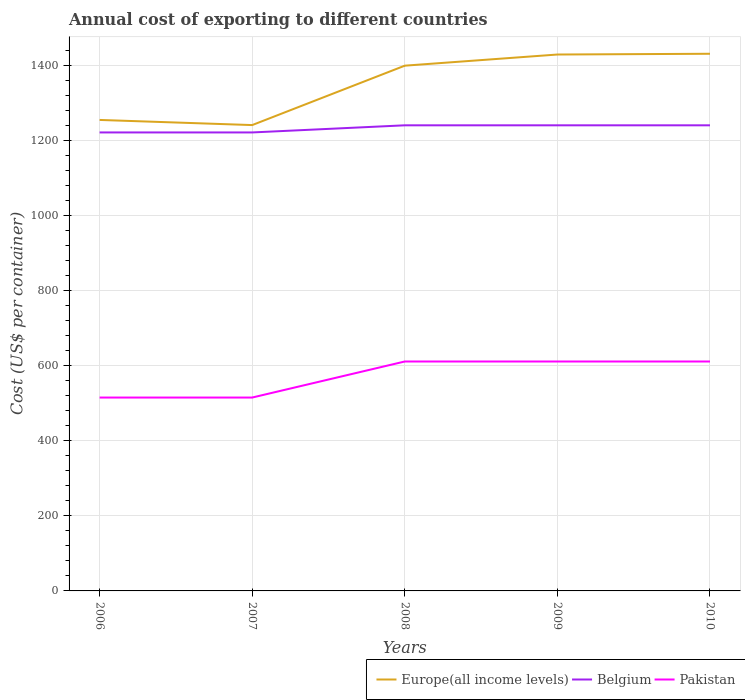Across all years, what is the maximum total annual cost of exporting in Pakistan?
Your answer should be compact. 515. What is the total total annual cost of exporting in Pakistan in the graph?
Give a very brief answer. 0. What is the difference between the highest and the second highest total annual cost of exporting in Belgium?
Keep it short and to the point. 19. What is the difference between the highest and the lowest total annual cost of exporting in Pakistan?
Your answer should be compact. 3. How many lines are there?
Offer a terse response. 3. Does the graph contain grids?
Provide a short and direct response. Yes. How many legend labels are there?
Your response must be concise. 3. How are the legend labels stacked?
Provide a succinct answer. Horizontal. What is the title of the graph?
Your answer should be compact. Annual cost of exporting to different countries. Does "Ghana" appear as one of the legend labels in the graph?
Your answer should be very brief. No. What is the label or title of the Y-axis?
Make the answer very short. Cost (US$ per container). What is the Cost (US$ per container) of Europe(all income levels) in 2006?
Your answer should be compact. 1254.33. What is the Cost (US$ per container) of Belgium in 2006?
Ensure brevity in your answer.  1221. What is the Cost (US$ per container) of Pakistan in 2006?
Offer a very short reply. 515. What is the Cost (US$ per container) of Europe(all income levels) in 2007?
Your response must be concise. 1240.63. What is the Cost (US$ per container) of Belgium in 2007?
Your answer should be compact. 1221. What is the Cost (US$ per container) in Pakistan in 2007?
Your answer should be compact. 515. What is the Cost (US$ per container) in Europe(all income levels) in 2008?
Provide a succinct answer. 1398.83. What is the Cost (US$ per container) in Belgium in 2008?
Offer a very short reply. 1240. What is the Cost (US$ per container) in Pakistan in 2008?
Give a very brief answer. 611. What is the Cost (US$ per container) in Europe(all income levels) in 2009?
Give a very brief answer. 1428.52. What is the Cost (US$ per container) in Belgium in 2009?
Your answer should be compact. 1240. What is the Cost (US$ per container) in Pakistan in 2009?
Offer a terse response. 611. What is the Cost (US$ per container) in Europe(all income levels) in 2010?
Your answer should be compact. 1430.54. What is the Cost (US$ per container) of Belgium in 2010?
Offer a very short reply. 1240. What is the Cost (US$ per container) in Pakistan in 2010?
Make the answer very short. 611. Across all years, what is the maximum Cost (US$ per container) of Europe(all income levels)?
Your answer should be very brief. 1430.54. Across all years, what is the maximum Cost (US$ per container) in Belgium?
Your answer should be compact. 1240. Across all years, what is the maximum Cost (US$ per container) in Pakistan?
Your response must be concise. 611. Across all years, what is the minimum Cost (US$ per container) of Europe(all income levels)?
Keep it short and to the point. 1240.63. Across all years, what is the minimum Cost (US$ per container) of Belgium?
Offer a very short reply. 1221. Across all years, what is the minimum Cost (US$ per container) in Pakistan?
Make the answer very short. 515. What is the total Cost (US$ per container) of Europe(all income levels) in the graph?
Your answer should be very brief. 6752.85. What is the total Cost (US$ per container) in Belgium in the graph?
Provide a short and direct response. 6162. What is the total Cost (US$ per container) of Pakistan in the graph?
Your answer should be very brief. 2863. What is the difference between the Cost (US$ per container) of Europe(all income levels) in 2006 and that in 2007?
Provide a short and direct response. 13.7. What is the difference between the Cost (US$ per container) of Europe(all income levels) in 2006 and that in 2008?
Ensure brevity in your answer.  -144.5. What is the difference between the Cost (US$ per container) of Pakistan in 2006 and that in 2008?
Your response must be concise. -96. What is the difference between the Cost (US$ per container) of Europe(all income levels) in 2006 and that in 2009?
Give a very brief answer. -174.19. What is the difference between the Cost (US$ per container) of Pakistan in 2006 and that in 2009?
Offer a terse response. -96. What is the difference between the Cost (US$ per container) of Europe(all income levels) in 2006 and that in 2010?
Keep it short and to the point. -176.22. What is the difference between the Cost (US$ per container) in Pakistan in 2006 and that in 2010?
Provide a short and direct response. -96. What is the difference between the Cost (US$ per container) of Europe(all income levels) in 2007 and that in 2008?
Your answer should be compact. -158.2. What is the difference between the Cost (US$ per container) in Pakistan in 2007 and that in 2008?
Keep it short and to the point. -96. What is the difference between the Cost (US$ per container) in Europe(all income levels) in 2007 and that in 2009?
Your answer should be compact. -187.89. What is the difference between the Cost (US$ per container) in Belgium in 2007 and that in 2009?
Your response must be concise. -19. What is the difference between the Cost (US$ per container) of Pakistan in 2007 and that in 2009?
Offer a terse response. -96. What is the difference between the Cost (US$ per container) of Europe(all income levels) in 2007 and that in 2010?
Offer a very short reply. -189.91. What is the difference between the Cost (US$ per container) in Belgium in 2007 and that in 2010?
Keep it short and to the point. -19. What is the difference between the Cost (US$ per container) of Pakistan in 2007 and that in 2010?
Provide a succinct answer. -96. What is the difference between the Cost (US$ per container) of Europe(all income levels) in 2008 and that in 2009?
Offer a very short reply. -29.69. What is the difference between the Cost (US$ per container) of Pakistan in 2008 and that in 2009?
Give a very brief answer. 0. What is the difference between the Cost (US$ per container) in Europe(all income levels) in 2008 and that in 2010?
Your answer should be compact. -31.71. What is the difference between the Cost (US$ per container) of Belgium in 2008 and that in 2010?
Your answer should be compact. 0. What is the difference between the Cost (US$ per container) of Pakistan in 2008 and that in 2010?
Offer a very short reply. 0. What is the difference between the Cost (US$ per container) of Europe(all income levels) in 2009 and that in 2010?
Your response must be concise. -2.02. What is the difference between the Cost (US$ per container) in Pakistan in 2009 and that in 2010?
Make the answer very short. 0. What is the difference between the Cost (US$ per container) of Europe(all income levels) in 2006 and the Cost (US$ per container) of Belgium in 2007?
Your answer should be compact. 33.33. What is the difference between the Cost (US$ per container) in Europe(all income levels) in 2006 and the Cost (US$ per container) in Pakistan in 2007?
Your answer should be compact. 739.33. What is the difference between the Cost (US$ per container) in Belgium in 2006 and the Cost (US$ per container) in Pakistan in 2007?
Offer a terse response. 706. What is the difference between the Cost (US$ per container) of Europe(all income levels) in 2006 and the Cost (US$ per container) of Belgium in 2008?
Make the answer very short. 14.33. What is the difference between the Cost (US$ per container) of Europe(all income levels) in 2006 and the Cost (US$ per container) of Pakistan in 2008?
Ensure brevity in your answer.  643.33. What is the difference between the Cost (US$ per container) in Belgium in 2006 and the Cost (US$ per container) in Pakistan in 2008?
Give a very brief answer. 610. What is the difference between the Cost (US$ per container) of Europe(all income levels) in 2006 and the Cost (US$ per container) of Belgium in 2009?
Ensure brevity in your answer.  14.33. What is the difference between the Cost (US$ per container) in Europe(all income levels) in 2006 and the Cost (US$ per container) in Pakistan in 2009?
Offer a very short reply. 643.33. What is the difference between the Cost (US$ per container) in Belgium in 2006 and the Cost (US$ per container) in Pakistan in 2009?
Give a very brief answer. 610. What is the difference between the Cost (US$ per container) in Europe(all income levels) in 2006 and the Cost (US$ per container) in Belgium in 2010?
Offer a very short reply. 14.33. What is the difference between the Cost (US$ per container) of Europe(all income levels) in 2006 and the Cost (US$ per container) of Pakistan in 2010?
Give a very brief answer. 643.33. What is the difference between the Cost (US$ per container) in Belgium in 2006 and the Cost (US$ per container) in Pakistan in 2010?
Provide a succinct answer. 610. What is the difference between the Cost (US$ per container) of Europe(all income levels) in 2007 and the Cost (US$ per container) of Belgium in 2008?
Ensure brevity in your answer.  0.63. What is the difference between the Cost (US$ per container) in Europe(all income levels) in 2007 and the Cost (US$ per container) in Pakistan in 2008?
Your response must be concise. 629.63. What is the difference between the Cost (US$ per container) in Belgium in 2007 and the Cost (US$ per container) in Pakistan in 2008?
Your answer should be very brief. 610. What is the difference between the Cost (US$ per container) in Europe(all income levels) in 2007 and the Cost (US$ per container) in Belgium in 2009?
Provide a short and direct response. 0.63. What is the difference between the Cost (US$ per container) of Europe(all income levels) in 2007 and the Cost (US$ per container) of Pakistan in 2009?
Provide a short and direct response. 629.63. What is the difference between the Cost (US$ per container) in Belgium in 2007 and the Cost (US$ per container) in Pakistan in 2009?
Your answer should be very brief. 610. What is the difference between the Cost (US$ per container) of Europe(all income levels) in 2007 and the Cost (US$ per container) of Belgium in 2010?
Make the answer very short. 0.63. What is the difference between the Cost (US$ per container) in Europe(all income levels) in 2007 and the Cost (US$ per container) in Pakistan in 2010?
Offer a very short reply. 629.63. What is the difference between the Cost (US$ per container) in Belgium in 2007 and the Cost (US$ per container) in Pakistan in 2010?
Your answer should be compact. 610. What is the difference between the Cost (US$ per container) in Europe(all income levels) in 2008 and the Cost (US$ per container) in Belgium in 2009?
Your response must be concise. 158.83. What is the difference between the Cost (US$ per container) of Europe(all income levels) in 2008 and the Cost (US$ per container) of Pakistan in 2009?
Keep it short and to the point. 787.83. What is the difference between the Cost (US$ per container) in Belgium in 2008 and the Cost (US$ per container) in Pakistan in 2009?
Keep it short and to the point. 629. What is the difference between the Cost (US$ per container) in Europe(all income levels) in 2008 and the Cost (US$ per container) in Belgium in 2010?
Your response must be concise. 158.83. What is the difference between the Cost (US$ per container) of Europe(all income levels) in 2008 and the Cost (US$ per container) of Pakistan in 2010?
Your response must be concise. 787.83. What is the difference between the Cost (US$ per container) of Belgium in 2008 and the Cost (US$ per container) of Pakistan in 2010?
Give a very brief answer. 629. What is the difference between the Cost (US$ per container) of Europe(all income levels) in 2009 and the Cost (US$ per container) of Belgium in 2010?
Your answer should be very brief. 188.52. What is the difference between the Cost (US$ per container) in Europe(all income levels) in 2009 and the Cost (US$ per container) in Pakistan in 2010?
Offer a terse response. 817.52. What is the difference between the Cost (US$ per container) in Belgium in 2009 and the Cost (US$ per container) in Pakistan in 2010?
Provide a succinct answer. 629. What is the average Cost (US$ per container) in Europe(all income levels) per year?
Offer a very short reply. 1350.57. What is the average Cost (US$ per container) in Belgium per year?
Offer a terse response. 1232.4. What is the average Cost (US$ per container) of Pakistan per year?
Your answer should be compact. 572.6. In the year 2006, what is the difference between the Cost (US$ per container) of Europe(all income levels) and Cost (US$ per container) of Belgium?
Your response must be concise. 33.33. In the year 2006, what is the difference between the Cost (US$ per container) in Europe(all income levels) and Cost (US$ per container) in Pakistan?
Offer a terse response. 739.33. In the year 2006, what is the difference between the Cost (US$ per container) of Belgium and Cost (US$ per container) of Pakistan?
Offer a terse response. 706. In the year 2007, what is the difference between the Cost (US$ per container) of Europe(all income levels) and Cost (US$ per container) of Belgium?
Offer a terse response. 19.63. In the year 2007, what is the difference between the Cost (US$ per container) of Europe(all income levels) and Cost (US$ per container) of Pakistan?
Your answer should be very brief. 725.63. In the year 2007, what is the difference between the Cost (US$ per container) of Belgium and Cost (US$ per container) of Pakistan?
Your answer should be very brief. 706. In the year 2008, what is the difference between the Cost (US$ per container) in Europe(all income levels) and Cost (US$ per container) in Belgium?
Provide a short and direct response. 158.83. In the year 2008, what is the difference between the Cost (US$ per container) of Europe(all income levels) and Cost (US$ per container) of Pakistan?
Provide a short and direct response. 787.83. In the year 2008, what is the difference between the Cost (US$ per container) of Belgium and Cost (US$ per container) of Pakistan?
Provide a short and direct response. 629. In the year 2009, what is the difference between the Cost (US$ per container) of Europe(all income levels) and Cost (US$ per container) of Belgium?
Your answer should be compact. 188.52. In the year 2009, what is the difference between the Cost (US$ per container) in Europe(all income levels) and Cost (US$ per container) in Pakistan?
Your answer should be very brief. 817.52. In the year 2009, what is the difference between the Cost (US$ per container) in Belgium and Cost (US$ per container) in Pakistan?
Offer a terse response. 629. In the year 2010, what is the difference between the Cost (US$ per container) of Europe(all income levels) and Cost (US$ per container) of Belgium?
Offer a very short reply. 190.54. In the year 2010, what is the difference between the Cost (US$ per container) in Europe(all income levels) and Cost (US$ per container) in Pakistan?
Provide a succinct answer. 819.54. In the year 2010, what is the difference between the Cost (US$ per container) of Belgium and Cost (US$ per container) of Pakistan?
Provide a short and direct response. 629. What is the ratio of the Cost (US$ per container) of Belgium in 2006 to that in 2007?
Your answer should be very brief. 1. What is the ratio of the Cost (US$ per container) of Europe(all income levels) in 2006 to that in 2008?
Make the answer very short. 0.9. What is the ratio of the Cost (US$ per container) in Belgium in 2006 to that in 2008?
Your answer should be very brief. 0.98. What is the ratio of the Cost (US$ per container) of Pakistan in 2006 to that in 2008?
Your response must be concise. 0.84. What is the ratio of the Cost (US$ per container) of Europe(all income levels) in 2006 to that in 2009?
Provide a succinct answer. 0.88. What is the ratio of the Cost (US$ per container) in Belgium in 2006 to that in 2009?
Provide a succinct answer. 0.98. What is the ratio of the Cost (US$ per container) in Pakistan in 2006 to that in 2009?
Offer a very short reply. 0.84. What is the ratio of the Cost (US$ per container) in Europe(all income levels) in 2006 to that in 2010?
Your answer should be very brief. 0.88. What is the ratio of the Cost (US$ per container) in Belgium in 2006 to that in 2010?
Make the answer very short. 0.98. What is the ratio of the Cost (US$ per container) in Pakistan in 2006 to that in 2010?
Offer a terse response. 0.84. What is the ratio of the Cost (US$ per container) in Europe(all income levels) in 2007 to that in 2008?
Keep it short and to the point. 0.89. What is the ratio of the Cost (US$ per container) of Belgium in 2007 to that in 2008?
Make the answer very short. 0.98. What is the ratio of the Cost (US$ per container) in Pakistan in 2007 to that in 2008?
Provide a short and direct response. 0.84. What is the ratio of the Cost (US$ per container) of Europe(all income levels) in 2007 to that in 2009?
Ensure brevity in your answer.  0.87. What is the ratio of the Cost (US$ per container) in Belgium in 2007 to that in 2009?
Make the answer very short. 0.98. What is the ratio of the Cost (US$ per container) of Pakistan in 2007 to that in 2009?
Offer a terse response. 0.84. What is the ratio of the Cost (US$ per container) of Europe(all income levels) in 2007 to that in 2010?
Provide a short and direct response. 0.87. What is the ratio of the Cost (US$ per container) in Belgium in 2007 to that in 2010?
Ensure brevity in your answer.  0.98. What is the ratio of the Cost (US$ per container) in Pakistan in 2007 to that in 2010?
Provide a succinct answer. 0.84. What is the ratio of the Cost (US$ per container) of Europe(all income levels) in 2008 to that in 2009?
Your response must be concise. 0.98. What is the ratio of the Cost (US$ per container) in Belgium in 2008 to that in 2009?
Make the answer very short. 1. What is the ratio of the Cost (US$ per container) of Europe(all income levels) in 2008 to that in 2010?
Ensure brevity in your answer.  0.98. What is the ratio of the Cost (US$ per container) of Belgium in 2008 to that in 2010?
Make the answer very short. 1. What is the ratio of the Cost (US$ per container) in Pakistan in 2008 to that in 2010?
Your answer should be compact. 1. What is the ratio of the Cost (US$ per container) of Europe(all income levels) in 2009 to that in 2010?
Provide a short and direct response. 1. What is the ratio of the Cost (US$ per container) in Belgium in 2009 to that in 2010?
Your answer should be compact. 1. What is the ratio of the Cost (US$ per container) in Pakistan in 2009 to that in 2010?
Ensure brevity in your answer.  1. What is the difference between the highest and the second highest Cost (US$ per container) of Europe(all income levels)?
Your answer should be very brief. 2.02. What is the difference between the highest and the second highest Cost (US$ per container) of Pakistan?
Your response must be concise. 0. What is the difference between the highest and the lowest Cost (US$ per container) in Europe(all income levels)?
Your response must be concise. 189.91. What is the difference between the highest and the lowest Cost (US$ per container) of Pakistan?
Make the answer very short. 96. 